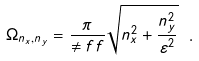<formula> <loc_0><loc_0><loc_500><loc_500>\Omega _ { n _ { x } , n _ { y } } = \frac { \pi } { \ne f f } \sqrt { n _ { x } ^ { 2 } + \frac { n _ { y } ^ { 2 } } { \varepsilon ^ { 2 } } } \ .</formula> 